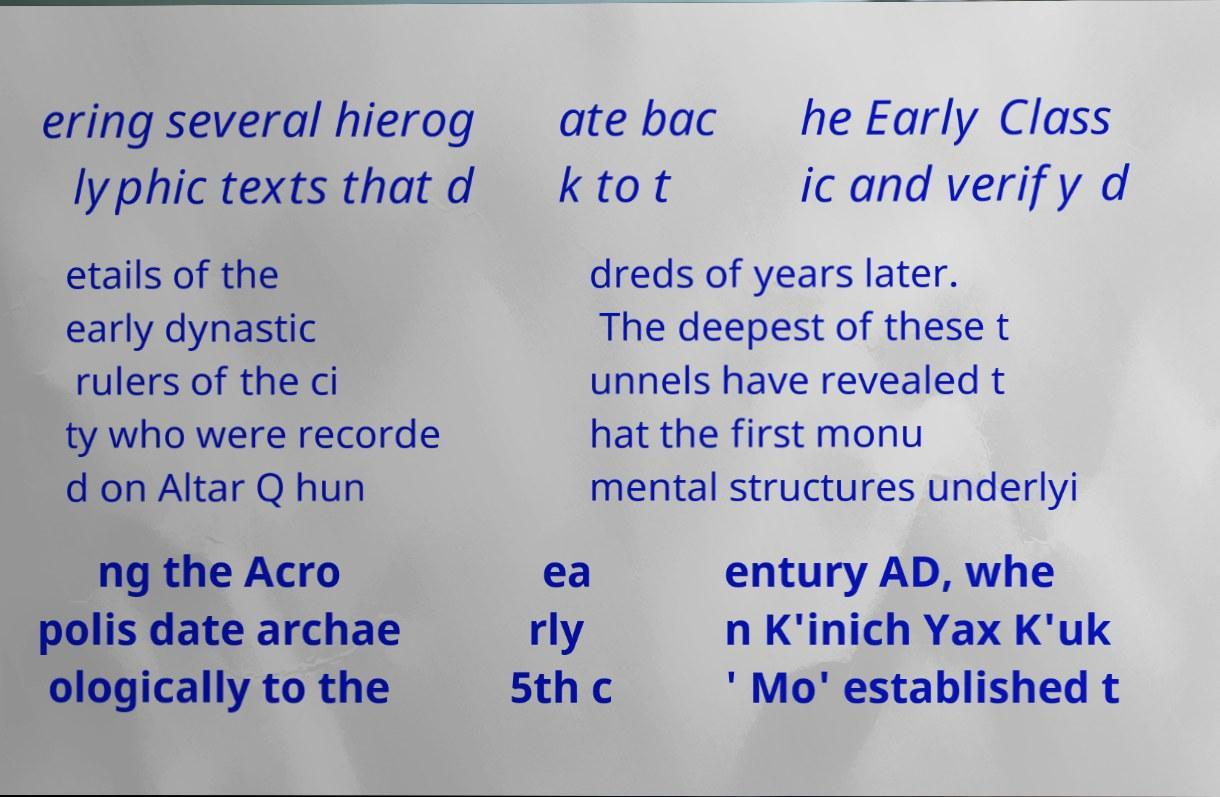What messages or text are displayed in this image? I need them in a readable, typed format. ering several hierog lyphic texts that d ate bac k to t he Early Class ic and verify d etails of the early dynastic rulers of the ci ty who were recorde d on Altar Q hun dreds of years later. The deepest of these t unnels have revealed t hat the first monu mental structures underlyi ng the Acro polis date archae ologically to the ea rly 5th c entury AD, whe n K'inich Yax K'uk ' Mo' established t 